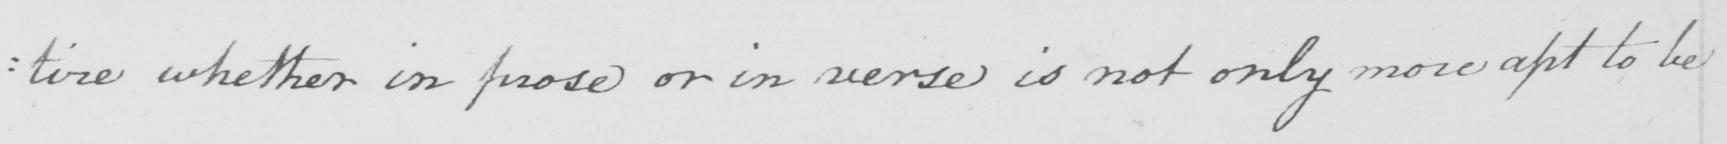Please provide the text content of this handwritten line. : tire whether in prose or in verse is not only more apt to be 